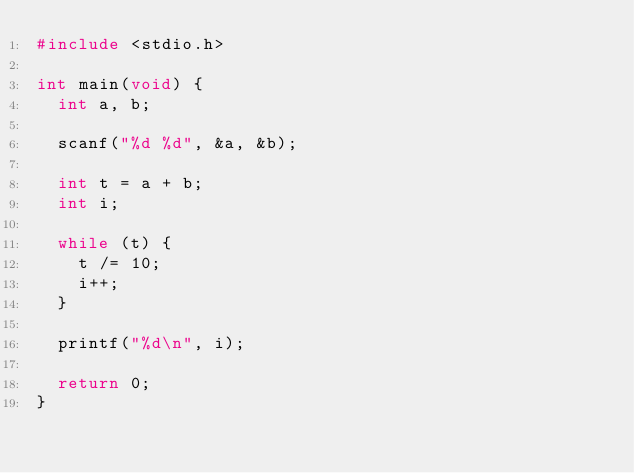<code> <loc_0><loc_0><loc_500><loc_500><_C_>#include <stdio.h>

int main(void) {
  int a, b;

  scanf("%d %d", &a, &b);

  int t = a + b;
  int i;

  while (t) {
    t /= 10;
    i++;
  }

  printf("%d\n", i);

  return 0;
}</code> 